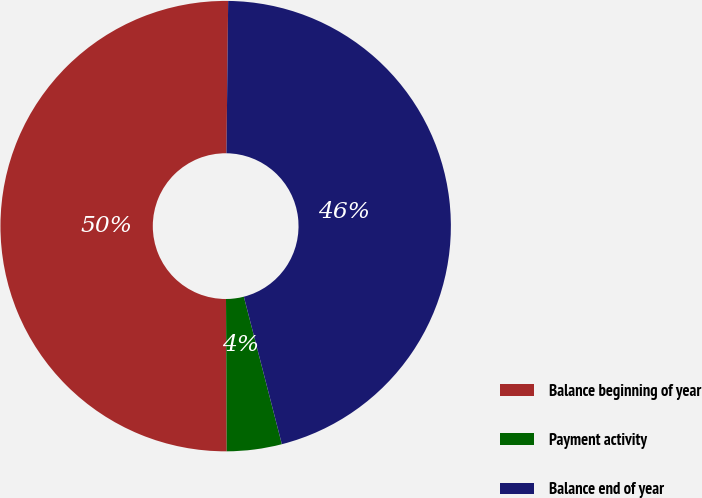Convert chart. <chart><loc_0><loc_0><loc_500><loc_500><pie_chart><fcel>Balance beginning of year<fcel>Payment activity<fcel>Balance end of year<nl><fcel>50.25%<fcel>3.94%<fcel>45.81%<nl></chart> 